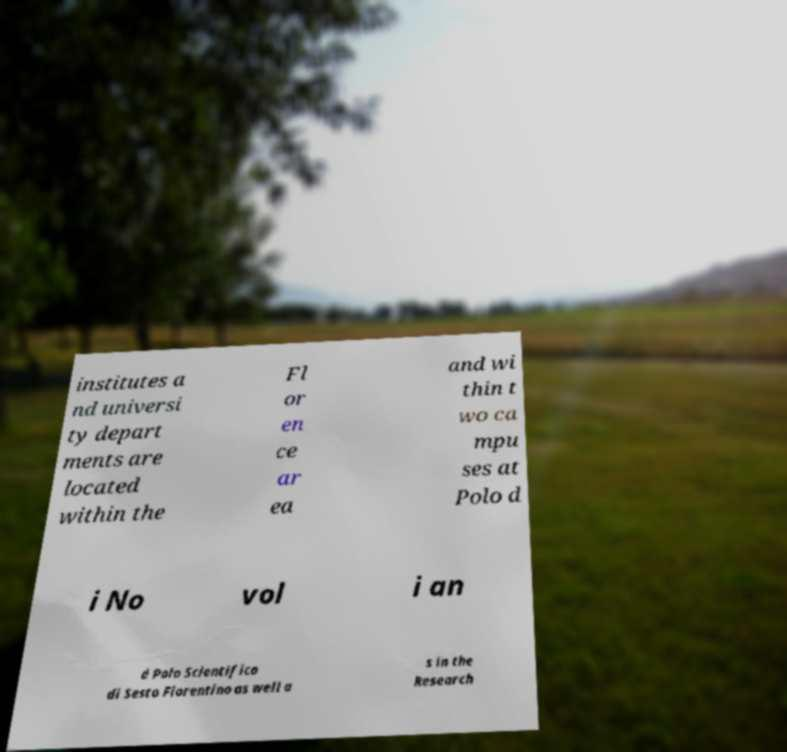Could you extract and type out the text from this image? institutes a nd universi ty depart ments are located within the Fl or en ce ar ea and wi thin t wo ca mpu ses at Polo d i No vol i an d Polo Scientifico di Sesto Fiorentino as well a s in the Research 